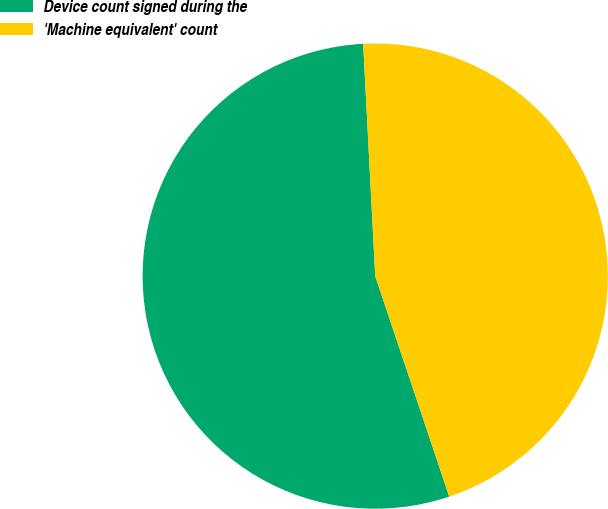Convert chart. <chart><loc_0><loc_0><loc_500><loc_500><pie_chart><fcel>Device count signed during the<fcel>'Machine equivalent' count<nl><fcel>54.33%<fcel>45.67%<nl></chart> 